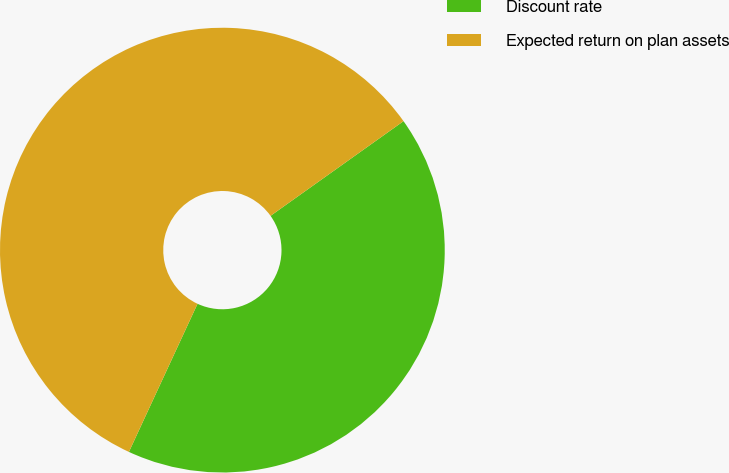<chart> <loc_0><loc_0><loc_500><loc_500><pie_chart><fcel>Discount rate<fcel>Expected return on plan assets<nl><fcel>41.75%<fcel>58.25%<nl></chart> 